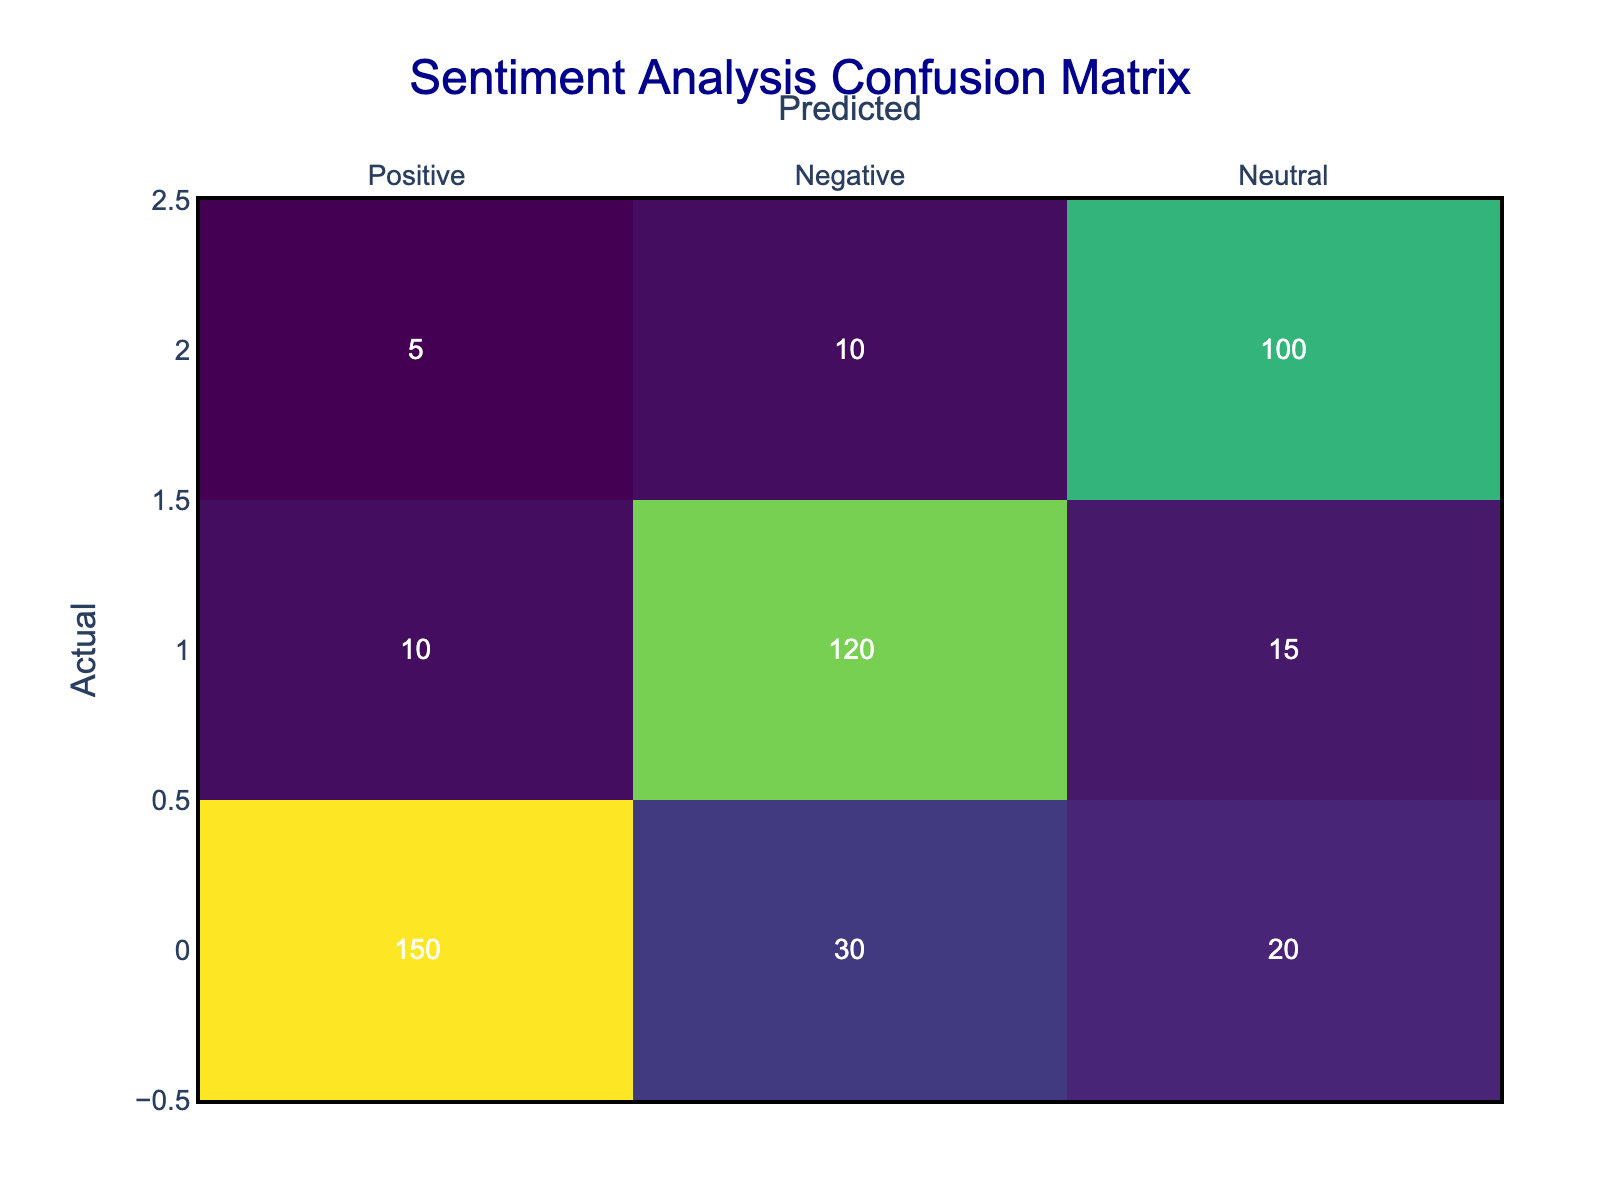What is the number of incorrectly predicted positive posts? The number of incorrectly predicted positive posts is the sum of negative and neutral predictions for the actual positive posts. From the table, we see 30 negative and 20 neutral predictions for actual positive posts, therefore the total is 30 + 20 = 50.
Answer: 50 What percentage of actual positive posts were correctly classified? To find the percentage of correctly classified positive posts, we take the number of true positive predictions (150) and divide it by the total number of actual positive posts (150 + 30 + 20 = 200). The calculation is (150 / 200) * 100, which equals 75%.
Answer: 75% What is the total number of neutral predictions? To get the total number of neutral predictions, we sum the neutral counts for each actual class: 20 (from actual positive) + 15 (from actual negative) + 100 (from actual neutral) equals 135 neutral predictions in total.
Answer: 135 Is the number of false negatives greater than the number of false positives? False negatives are the cases where actual positive posts were misclassified as either negative or neutral. This is the sum of 30 and 20 (for negative and neutral predictions from actual positives), which is 50. False positives are where actual negative or neutral posts were misclassified as positive, which counts as 10 + 5 (from actual negatives and actual neutrals), totaling 15. Comparing 50 and 15 shows that false negatives are indeed greater.
Answer: Yes What is the total number of actual negative posts? To find the total number of actual negative posts, we add the correctly predicted ones and the misclassified ones. The values from the table show 10 true negatives, 30 false positives, and 15 false negatives, summing to 10 + 120 + 15 = 145.
Answer: 145 What is the average number of neutral predictions across all actual classes? To find the average number of neutral predictions, we first sum the neutral predictions from each class: 20 (positive) + 15 (negative) + 100 (neutral) equals 135 neutral predictions. There are three groups (positive, negative, neutral), so we divide by 3. Thus, the average is 135 / 3 = 45.
Answer: 45 What is the total number of correct predictions made? The total number of correct predictions is the sum of true positives (150), true negatives (120), and true neutrals (100). Therefore, the total correct predictions amount to 150 + 120 + 100 = 370.
Answer: 370 